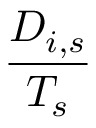<formula> <loc_0><loc_0><loc_500><loc_500>\frac { D _ { i , s } } { T _ { s } }</formula> 